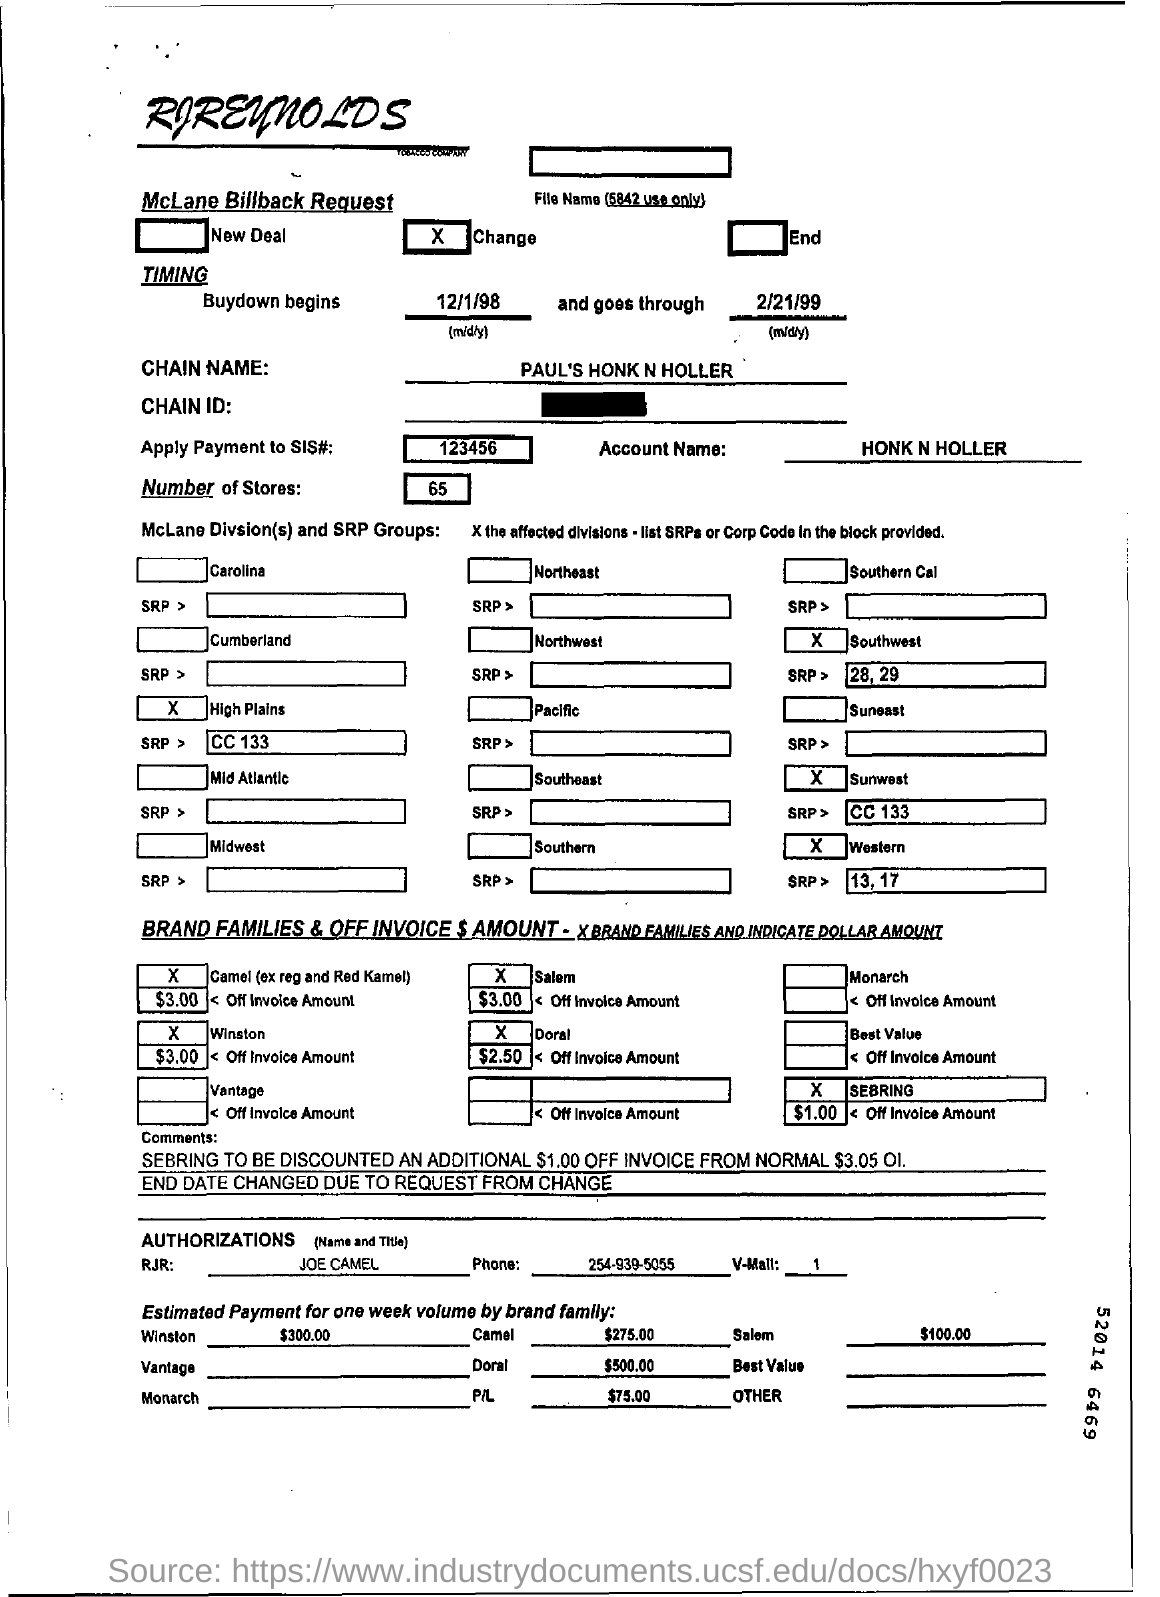What is the chain name
Provide a short and direct response. PAUL'S HONK N HOLLER. Whose name is mentioned in the account
Your answer should be very brief. HONK N HOLLER. How may number of stores are there
Give a very brief answer. 65. 